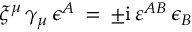Convert formula to latex. <formula><loc_0><loc_0><loc_500><loc_500>\xi ^ { \mu } \, \gamma _ { \mu } \, \epsilon ^ { A } \, = \, \pm i \, \varepsilon ^ { A B } \, \epsilon _ { B }</formula> 